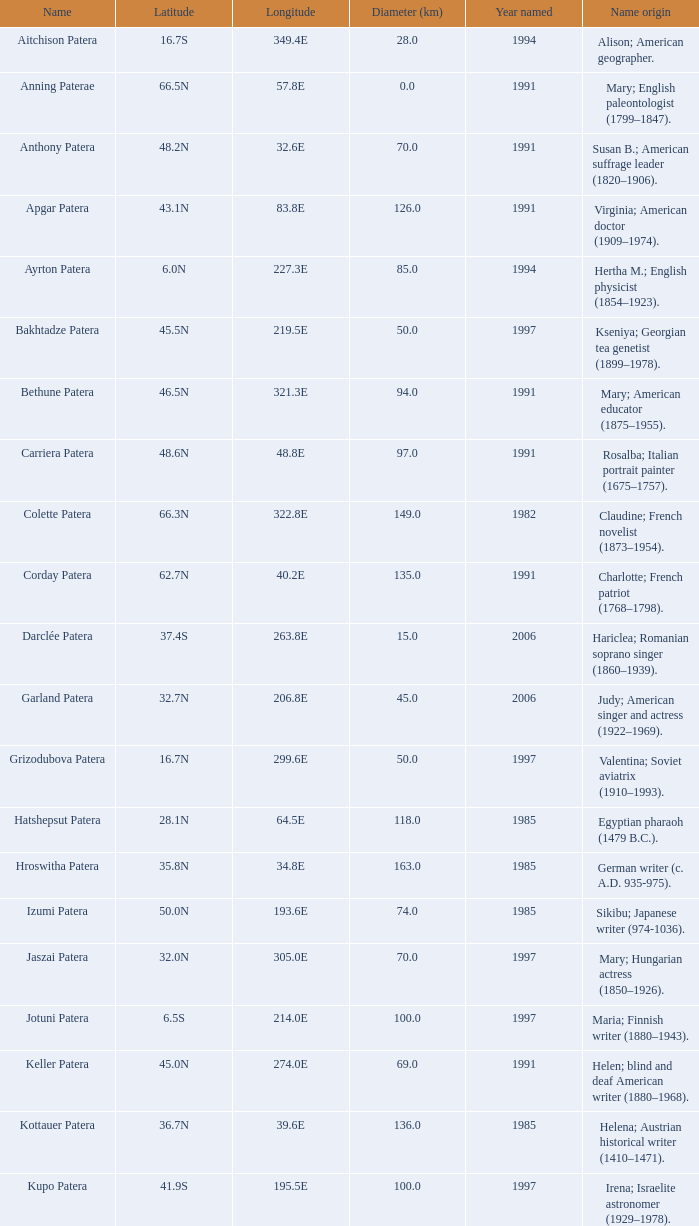What is the longitudinal coordinate of the feature known as razia patera? 197.8E. 